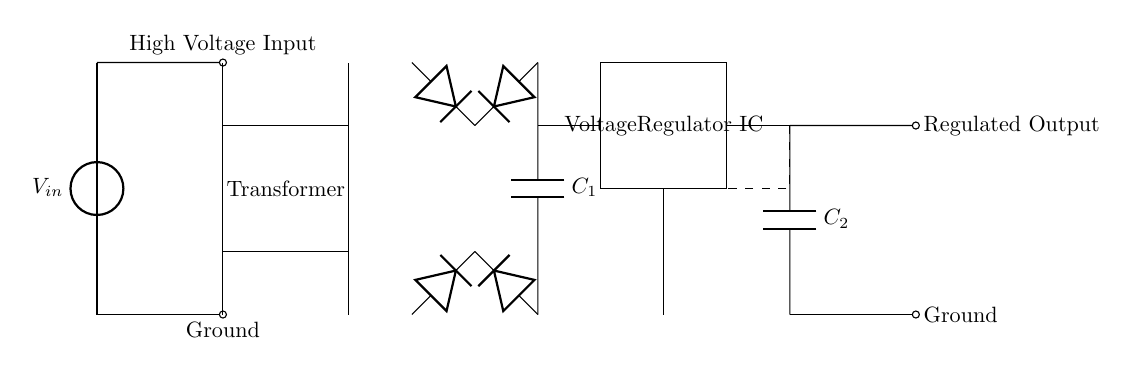What is the main function of the transformer in this circuit? The transformer's main function is to step down the voltage from the input to a desired level before it goes to the rectifier. In the diagram, it appears between the high voltage input and the rectifier bridge, confirming its role in voltage reduction.
Answer: Step down voltage What type of diodes are used in this circuit? The circuit diagram shows a bridge rectifier configuration made up of four diodes. This arrangement indicates the use of standard silicon diodes, which are common in rectifier setups to convert AC to DC.
Answer: Silicon diodes What is the purpose of the filter capacitor (C1) in this circuit? The filter capacitor (C1) smooths out the output voltage after the rectifier by reducing the ripple voltage, providing a steadier DC output. This function is crucial for applications requiring a stable voltage supply, particularly in high power devices.
Answer: Smooths DC output Where does the regulated output voltage originate from in the circuit? The regulated output voltage originates from the output of the voltage regulator IC, which takes the fluctuating DC voltage after the filter capacitor and ensures a stable, regulated voltage. This is indicated by the output section of the circuit.
Answer: Voltage regulator IC How many capacitors are present in this circuit? The circuit contains a total of two capacitors. One is the filter capacitor (C1) connected after the rectifier, and the other is the output capacitor (C2) before the regulated output, clearly shown as separate components in the diagram.
Answer: Two capacitors What is the role of the feedback line in this circuit? The feedback line provides a pathway for a portion of the output voltage to be sent back to the voltage regulator IC for regulation purposes. This feedback helps maintain the desired output voltage level against variations in input voltage or load conditions, as illustrated by the dashed line in the diagram.
Answer: Maintain output voltage 